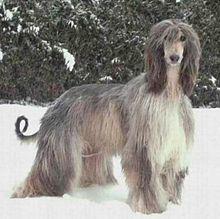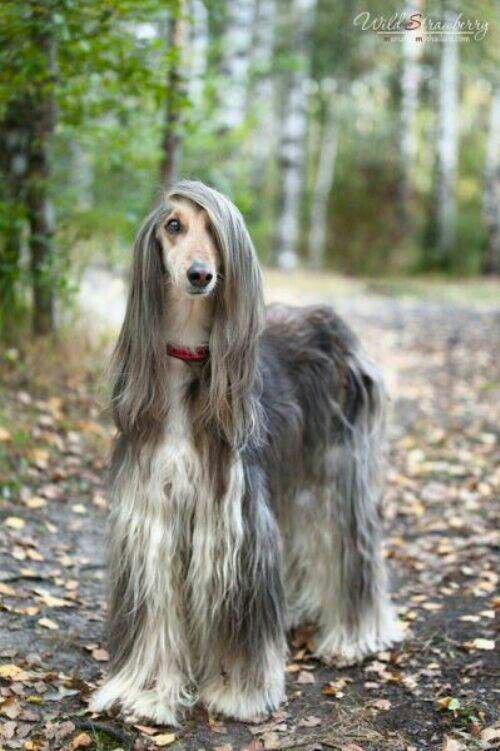The first image is the image on the left, the second image is the image on the right. Analyze the images presented: Is the assertion "In one image there is a lone afghan hound sitting outside in the grass." valid? Answer yes or no. No. The first image is the image on the left, the second image is the image on the right. Evaluate the accuracy of this statement regarding the images: "One image has a dog facing left but looking to the right.". Is it true? Answer yes or no. No. 